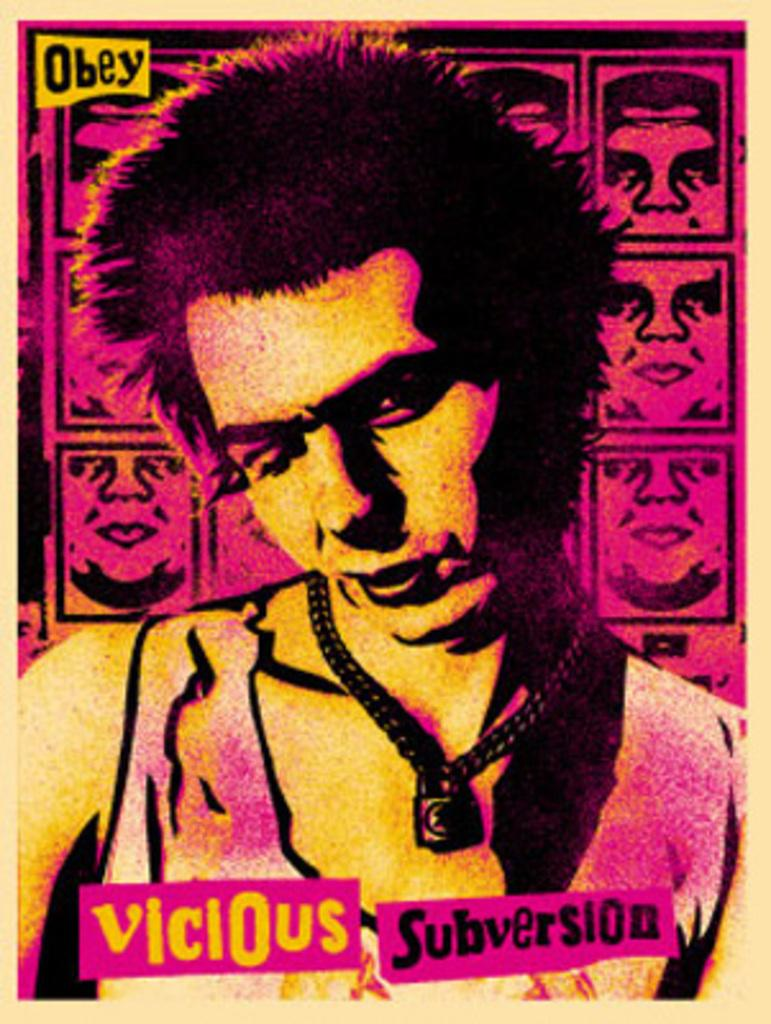What is present in the image that features an image and text? There is a poster in the image that contains an image of a man and text. Can you describe the image on the poster? The image on the poster features a man. What else can be found on the poster besides the image? There is text on the poster. How many lines are visible on the card in the image? There is no card present in the image, and therefore no lines can be observed. 